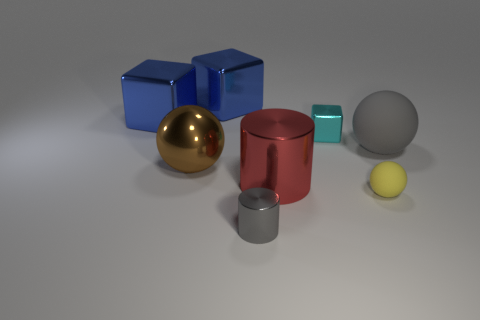Do the small yellow ball and the cyan thing have the same material?
Provide a succinct answer. No. The matte sphere that is the same size as the gray metallic cylinder is what color?
Give a very brief answer. Yellow. There is a object that is both in front of the large red metallic cylinder and behind the tiny metallic cylinder; what color is it?
Make the answer very short. Yellow. What size is the sphere that is the same color as the small shiny cylinder?
Your answer should be very brief. Large. What is the shape of the large object that is the same color as the tiny cylinder?
Make the answer very short. Sphere. There is a yellow matte sphere that is to the right of the gray object that is left of the large ball that is to the right of the tiny gray thing; what is its size?
Offer a very short reply. Small. What is the material of the tiny gray cylinder?
Ensure brevity in your answer.  Metal. Is the material of the large brown ball the same as the gray thing that is behind the brown shiny thing?
Give a very brief answer. No. Are there any other things that are the same color as the tiny cube?
Provide a short and direct response. No. Is there a big object in front of the tiny yellow object that is right of the large brown shiny ball that is on the left side of the small ball?
Your answer should be very brief. No. 